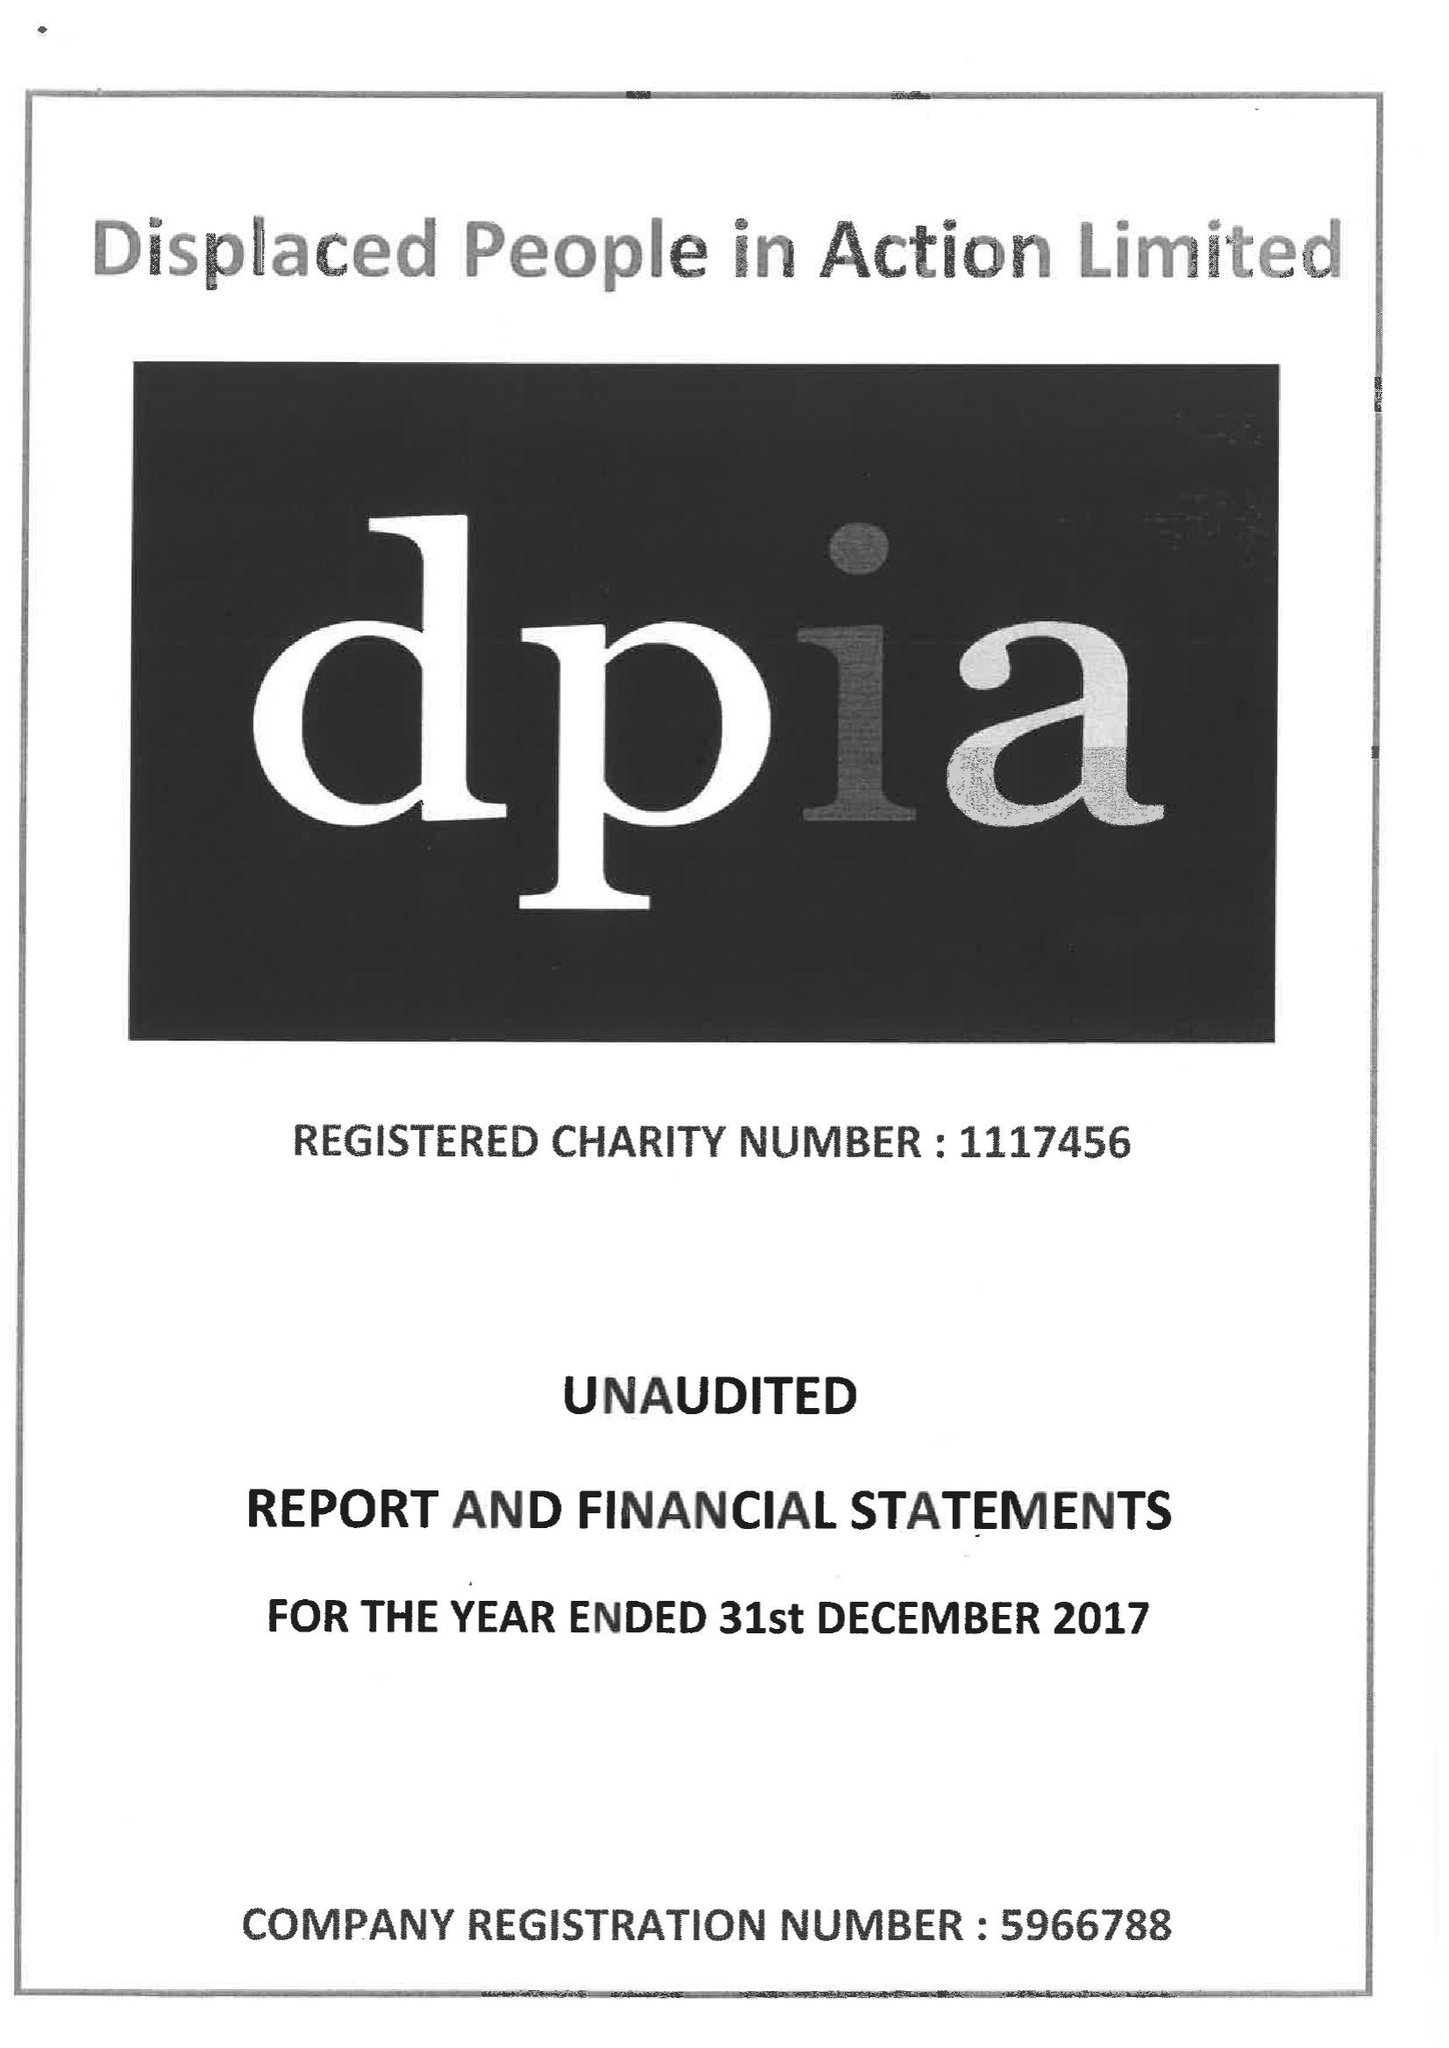What is the value for the spending_annually_in_british_pounds?
Answer the question using a single word or phrase. 472495.00 